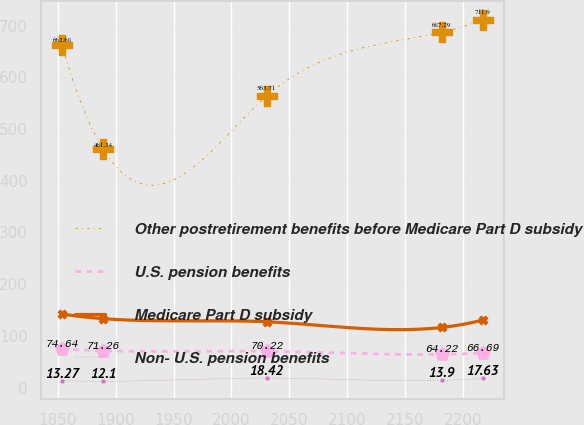Convert chart to OTSL. <chart><loc_0><loc_0><loc_500><loc_500><line_chart><ecel><fcel>Other postretirement benefits before Medicare Part D subsidy<fcel>U.S. pension benefits<fcel>Medicare Part D subsidy<fcel>Non- U.S. pension benefits<nl><fcel>1853.72<fcel>662.68<fcel>74.64<fcel>142.41<fcel>13.27<nl><fcel>1889.26<fcel>461.34<fcel>71.26<fcel>133.28<fcel>12.1<nl><fcel>2030.39<fcel>563.71<fcel>70.22<fcel>127.3<fcel>18.42<nl><fcel>2181.49<fcel>687.29<fcel>64.22<fcel>116.26<fcel>13.9<nl><fcel>2217.03<fcel>711.9<fcel>66.69<fcel>130.66<fcel>17.63<nl></chart> 